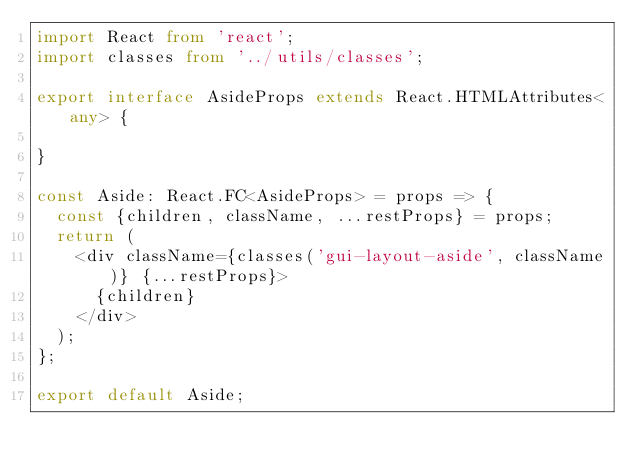Convert code to text. <code><loc_0><loc_0><loc_500><loc_500><_TypeScript_>import React from 'react';
import classes from '../utils/classes';

export interface AsideProps extends React.HTMLAttributes<any> {

}

const Aside: React.FC<AsideProps> = props => {
  const {children, className, ...restProps} = props;
  return (
    <div className={classes('gui-layout-aside', className)} {...restProps}>
      {children}
    </div>
  );
};

export default Aside;
</code> 